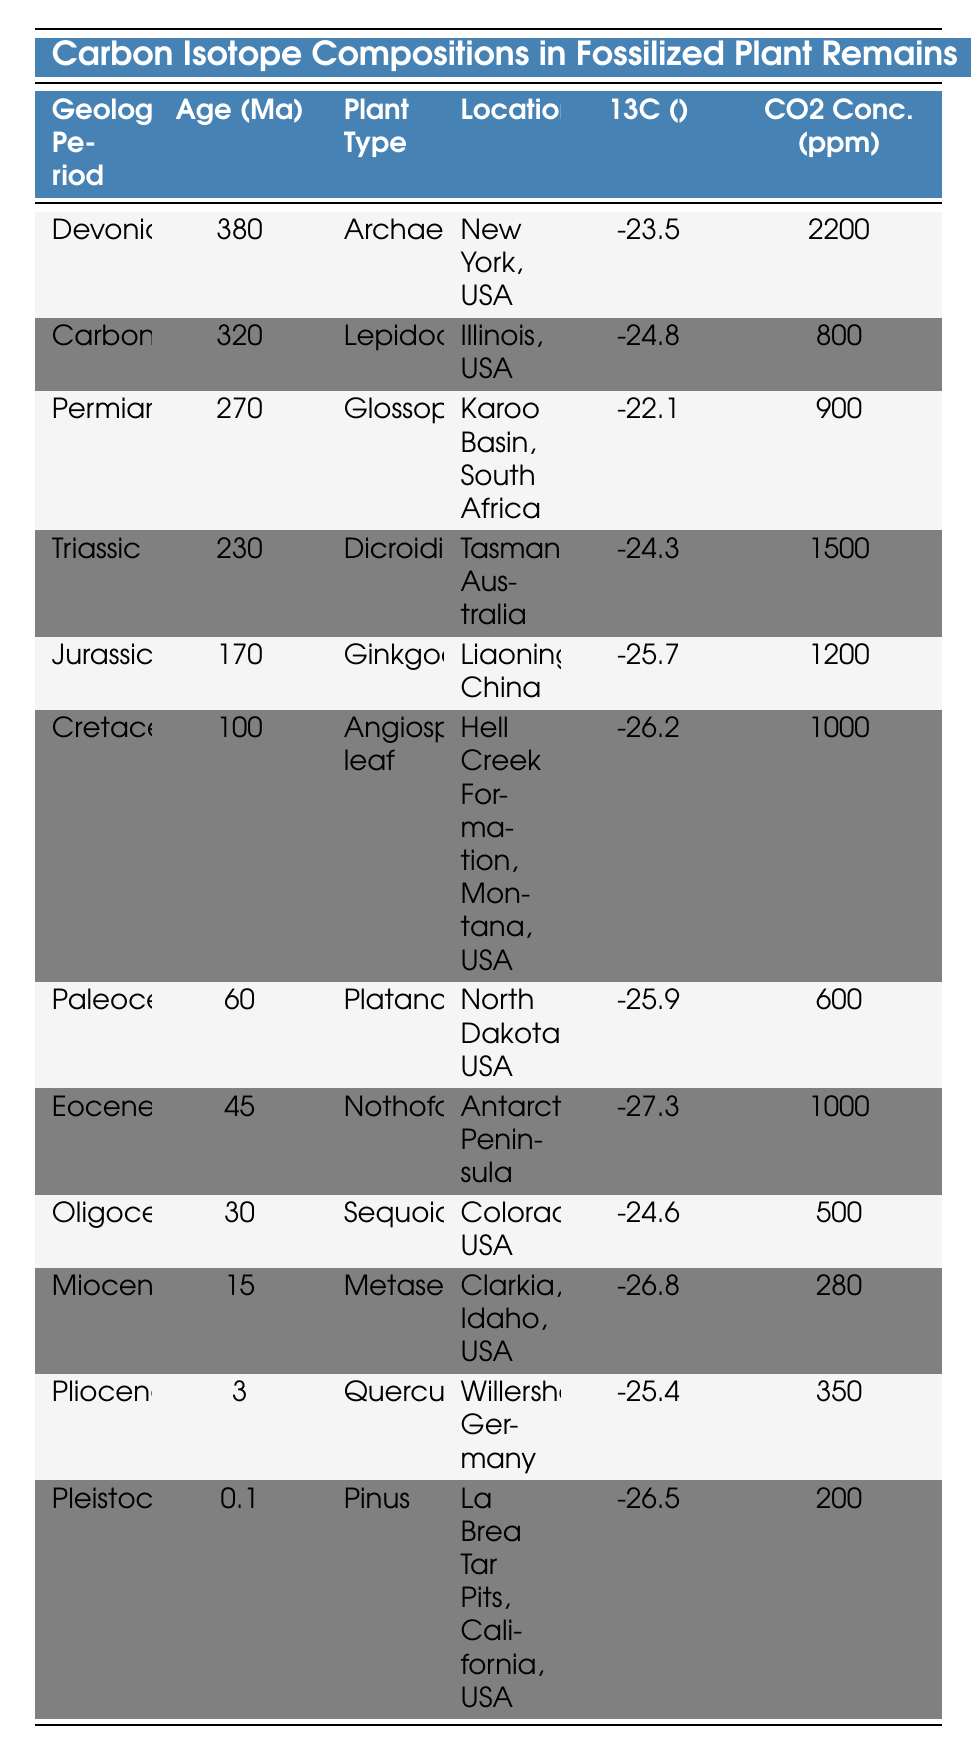What is the δ13C value for the plant type Metasequoia? The table lists the δ13C value for Metasequoia in the Miocene period as -26.8‰.
Answer: -26.8‰ Which geological period has the highest CO2 concentration in ppm? By examining the CO2 concentration values in the table, the Devonian period has the highest value at 2200 ppm.
Answer: 2200 ppm Is the δ13C value for Nothofagus more negative than that of Platanaceae? Yes, Nothofagus has a δ13C value of -27.3‰, which is more negative than Platanaceae's value of -25.9‰.
Answer: Yes What is the average CO2 concentration of the Cretaceous, Paleocene, and Eocene periods? The CO2 concentrations for these periods are: Cretaceous: 1000 ppm, Paleocene: 600 ppm, Eocene: 1000 ppm. The average is (1000 + 600 + 1000)/3 = 866.67 ppm.
Answer: 866.67 ppm In which geological period did the plant type Quercus exist, and what was its δ13C value? Quercus existed during the Pliocene period, and its δ13C value is -25.4‰.
Answer: Pliocene, -25.4‰ How does the δ13C value of Glossopteris compare to that of Ginkgoales? Glossopteris has a δ13C value of -22.1‰, while Ginkgoales has a value of -25.7‰. Glossopteris is less negative (higher) than Ginkgoales.
Answer: Glossopteris is less negative What is the difference in CO2 concentration between the Permian and the Triassic periods? The Permian has a CO2 concentration of 900 ppm and the Triassic has 1500 ppm. The difference is 1500 - 900 = 600 ppm.
Answer: 600 ppm Which plant type had the most negative δ13C value in the table? The table lists Nothofagus with the most negative δ13C value of -27.3‰ among all plant types.
Answer: Nothofagus What geological period comes immediately after the Jurassic, and what is its corresponding δ13C value? The Triassic period comes after the Jurassic, and its δ13C value is -24.3‰.
Answer: Triassic, -24.3‰ Calculate the median δ13C value from the fossilized plant remains listed in the table. The δ13C values in order are: -27.3, -27.0, -26.8, -26.5, -26.2, -25.9, -25.7, -25.4, -24.8, -24.6, -24.3, -22.1. There are 12 values, and the median is the average of the 6th and 7th values: (-25.9 + -25.7) / 2 = -25.8‰.
Answer: -25.8‰ Which plant types are found in North America? The table shows that the plant types Archaeopteris, Lepidodendron, Platanaceae, and Pinus are all found in North America.
Answer: Archaeopteris, Lepidodendron, Platanaceae, Pinus 